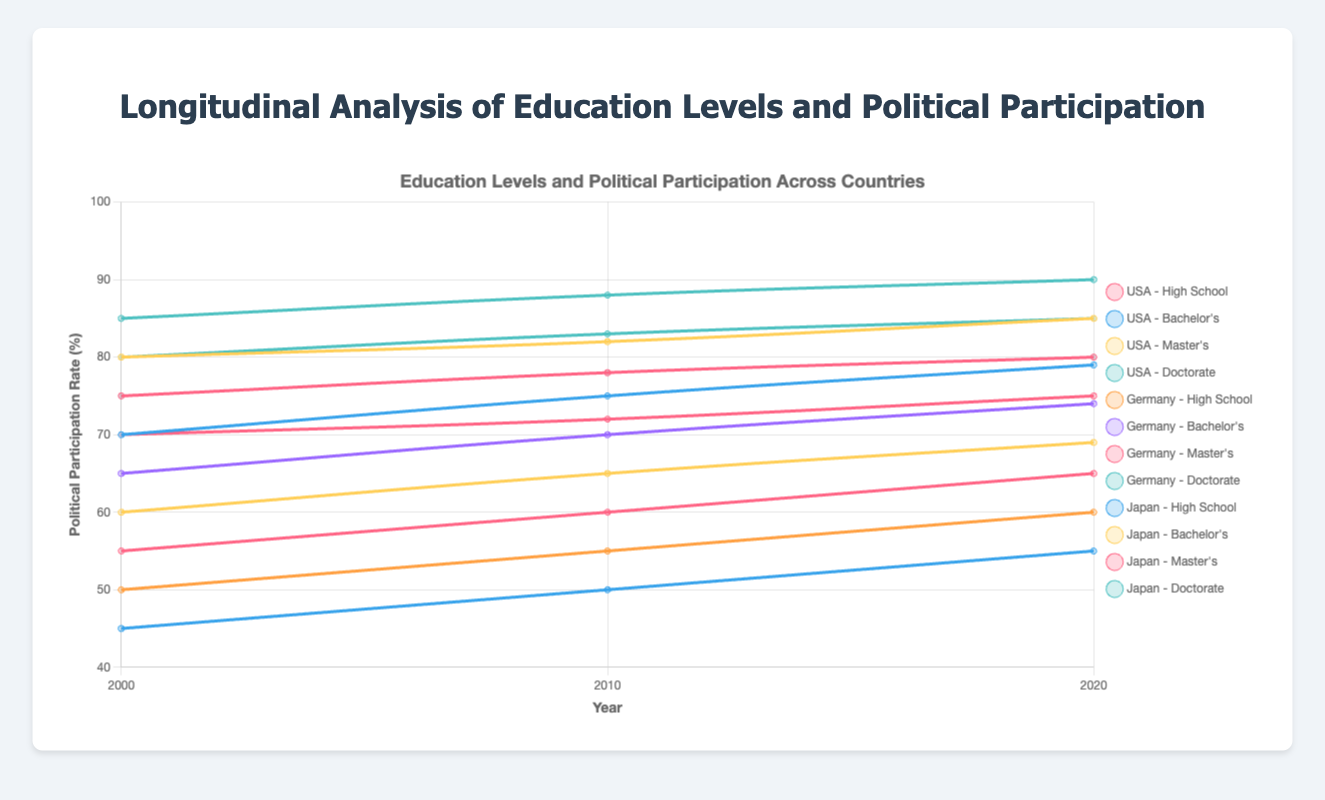Which educational level in the USA exhibited the highest increase in political participation rate from 2000 to 2020? The political participation rate for USA High School in 2000 is 55% and in 2020 is 65%, showing an increase of 10%. For Bachelor’s, the rate is 70% in 2000 and 79% in 2020, showing an increase of 9%. For Master's, the increase is from 80% to 85%, making it 5%. For Doctorate, the increase is from 85% to 90%, making it 5%. The highest increase is from the High School level with an increase of 10%.
Answer: High School Which country had the lowest political participation rate at the Master's level in 2020? The political participation rate in 2020 for Master's is 85% in the USA, 80% in Germany, and 75% in Japan. Thus, Japan had the lowest participation rate at the Master's level in 2020.
Answer: Japan What is the difference in political participation rate between High School and Bachelor’s level in Germany in 2010? In 2010, the political participation rate in Germany for High School is 55% and for Bachelor's is 70%. The difference between these rates is 70% - 55% = 15%.
Answer: 15% On average, how much did political participation increase across all education levels in Japan from 2000 to 2020? In 2000, the rates for Japan are High School 45%, Bachelor’s 60%, Master's 70%, Doctorate 75%. In 2020, they are High School 55%, Bachelor’s 69%, Master's 75%, Doctorate 80%. The increases are 10% (55-45), 9% (69-60), 5% (75-70), 5% (80-75). The average increase is (10 + 9 + 5 + 5) / 4 = 7.25%
Answer: 7.25% Which country had the greatest overall increase in political participation rate at the Bachelor's level from 2000 to 2020? For the Bachelor's level, the political participation rates in 2000 and 2020 are: USA 70% and 79% (increase of 9%), Germany 65% and 74% (increase of 9%), Japan 60% and 69% (increase of 9%). All three countries have an equal increase of 9%.
Answer: Equal Which visual attributes indicate the highest political participation rates in 2020 for the USA? The highest political participation rates for the USA in 2020 are shown with the tallest lines ending at the highest points, colored dark teal for Doctorate level reaching 90%, yellow for Master’s reaching 85%, and blue for Bachelor's reaching 79%.
Answer: Teal, Yellow, Blue Did the political participation rate for Doctorate level in Germany surpass 80% after 2000? In 2010, the political participation rate for the Doctorate level in Germany was 83%, and in 2020, it was 85%, both of which surpass 80%.
Answer: Yes Compare the change in political participation rates between High School and Master’s degrees in Japan from 2000 to 2020. In Japan, for High School, the rate increased from 45% in 2000 to 55% in 2020, an increase of 10%. For the Master’s degree, the rate increased from 70% to 75%, an increase of 5%.
Answer: High School: 10%, Master's: 5% What was the political participation rate for Bachelor's degree holders in Germany in 2010? The political participation rate for Bachelor’s degree holders in Germany in 2010 is indicated on the plot with the corresponding color and height for that year, displaying a rate of 70%.
Answer: 70% 